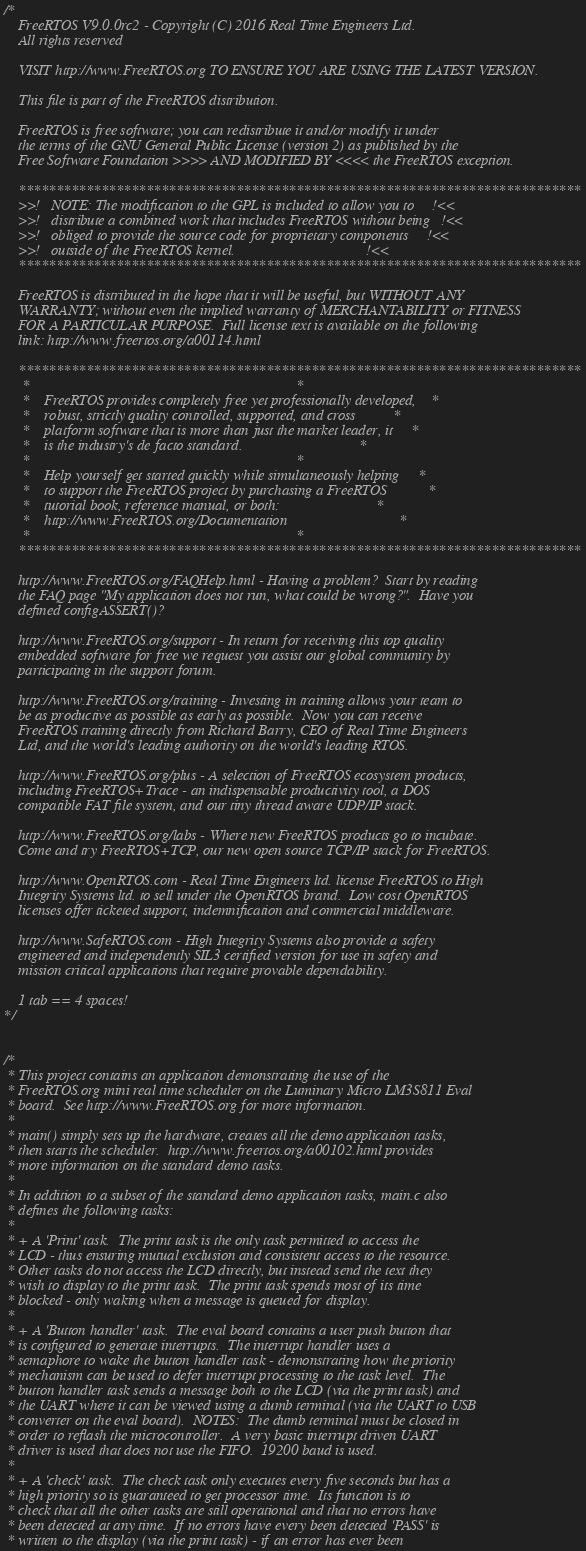<code> <loc_0><loc_0><loc_500><loc_500><_C_>/*
    FreeRTOS V9.0.0rc2 - Copyright (C) 2016 Real Time Engineers Ltd.
    All rights reserved

    VISIT http://www.FreeRTOS.org TO ENSURE YOU ARE USING THE LATEST VERSION.

    This file is part of the FreeRTOS distribution.

    FreeRTOS is free software; you can redistribute it and/or modify it under
    the terms of the GNU General Public License (version 2) as published by the
    Free Software Foundation >>>> AND MODIFIED BY <<<< the FreeRTOS exception.

    ***************************************************************************
    >>!   NOTE: The modification to the GPL is included to allow you to     !<<
    >>!   distribute a combined work that includes FreeRTOS without being   !<<
    >>!   obliged to provide the source code for proprietary components     !<<
    >>!   outside of the FreeRTOS kernel.                                   !<<
    ***************************************************************************

    FreeRTOS is distributed in the hope that it will be useful, but WITHOUT ANY
    WARRANTY; without even the implied warranty of MERCHANTABILITY or FITNESS
    FOR A PARTICULAR PURPOSE.  Full license text is available on the following
    link: http://www.freertos.org/a00114.html

    ***************************************************************************
     *                                                                       *
     *    FreeRTOS provides completely free yet professionally developed,    *
     *    robust, strictly quality controlled, supported, and cross          *
     *    platform software that is more than just the market leader, it     *
     *    is the industry's de facto standard.                               *
     *                                                                       *
     *    Help yourself get started quickly while simultaneously helping     *
     *    to support the FreeRTOS project by purchasing a FreeRTOS           *
     *    tutorial book, reference manual, or both:                          *
     *    http://www.FreeRTOS.org/Documentation                              *
     *                                                                       *
    ***************************************************************************

    http://www.FreeRTOS.org/FAQHelp.html - Having a problem?  Start by reading
    the FAQ page "My application does not run, what could be wrong?".  Have you
    defined configASSERT()?

    http://www.FreeRTOS.org/support - In return for receiving this top quality
    embedded software for free we request you assist our global community by
    participating in the support forum.

    http://www.FreeRTOS.org/training - Investing in training allows your team to
    be as productive as possible as early as possible.  Now you can receive
    FreeRTOS training directly from Richard Barry, CEO of Real Time Engineers
    Ltd, and the world's leading authority on the world's leading RTOS.

    http://www.FreeRTOS.org/plus - A selection of FreeRTOS ecosystem products,
    including FreeRTOS+Trace - an indispensable productivity tool, a DOS
    compatible FAT file system, and our tiny thread aware UDP/IP stack.

    http://www.FreeRTOS.org/labs - Where new FreeRTOS products go to incubate.
    Come and try FreeRTOS+TCP, our new open source TCP/IP stack for FreeRTOS.

    http://www.OpenRTOS.com - Real Time Engineers ltd. license FreeRTOS to High
    Integrity Systems ltd. to sell under the OpenRTOS brand.  Low cost OpenRTOS
    licenses offer ticketed support, indemnification and commercial middleware.

    http://www.SafeRTOS.com - High Integrity Systems also provide a safety
    engineered and independently SIL3 certified version for use in safety and
    mission critical applications that require provable dependability.

    1 tab == 4 spaces!
*/


/*
 * This project contains an application demonstrating the use of the 
 * FreeRTOS.org mini real time scheduler on the Luminary Micro LM3S811 Eval
 * board.  See http://www.FreeRTOS.org for more information.
 *
 * main() simply sets up the hardware, creates all the demo application tasks, 
 * then starts the scheduler.  http://www.freertos.org/a00102.html provides
 * more information on the standard demo tasks. 
 *
 * In addition to a subset of the standard demo application tasks, main.c also
 * defines the following tasks: 
 *
 * + A 'Print' task.  The print task is the only task permitted to access the
 * LCD - thus ensuring mutual exclusion and consistent access to the resource.
 * Other tasks do not access the LCD directly, but instead send the text they
 * wish to display to the print task.  The print task spends most of its time
 * blocked - only waking when a message is queued for display.
 *
 * + A 'Button handler' task.  The eval board contains a user push button that
 * is configured to generate interrupts.  The interrupt handler uses a 
 * semaphore to wake the button handler task - demonstrating how the priority 
 * mechanism can be used to defer interrupt processing to the task level.  The
 * button handler task sends a message both to the LCD (via the print task) and
 * the UART where it can be viewed using a dumb terminal (via the UART to USB
 * converter on the eval board).  NOTES:  The dumb terminal must be closed in 
 * order to reflash the microcontroller.  A very basic interrupt driven UART
 * driver is used that does not use the FIFO.  19200 baud is used.
 *
 * + A 'check' task.  The check task only executes every five seconds but has a
 * high priority so is guaranteed to get processor time.  Its function is to
 * check that all the other tasks are still operational and that no errors have
 * been detected at any time.  If no errors have every been detected 'PASS' is
 * written to the display (via the print task) - if an error has ever been</code> 